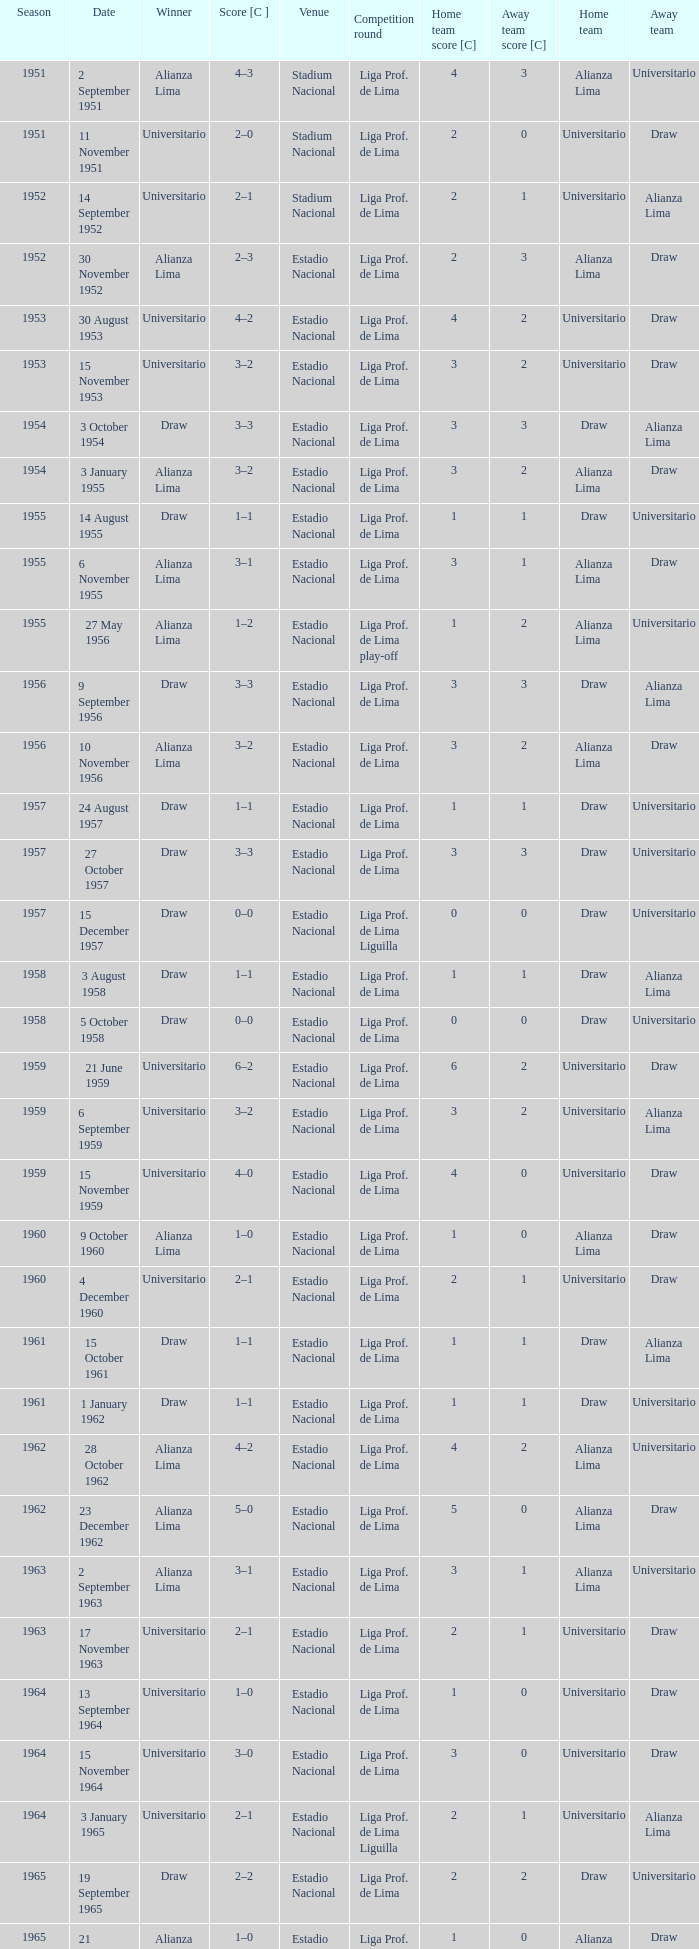What is the newest season associated with a date of 27 october 1957? 1957.0. 